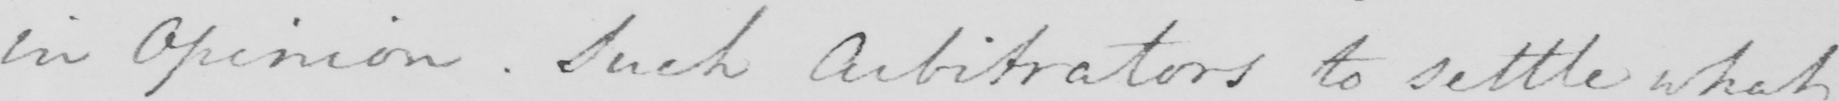Please transcribe the handwritten text in this image. in Opinion . Such Arbitrators to settle what 